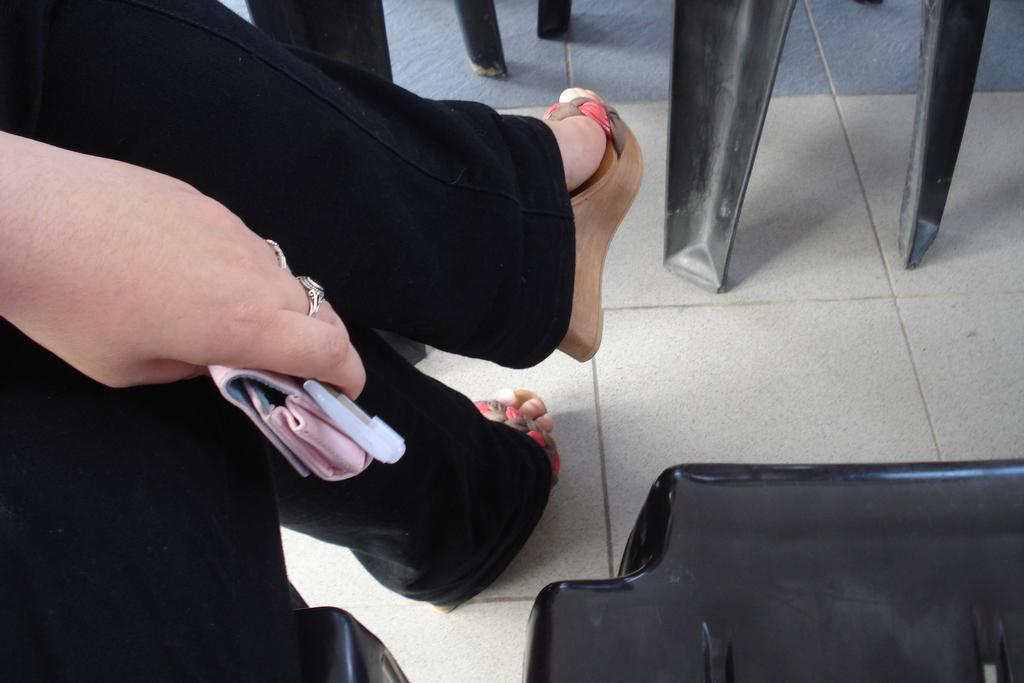What type of furniture is present in the image? There are chairs in the image. What is the person on the left side of the image doing? The person is sitting on the left side of the image. What is the person holding in their hand? The person is holding a pen and a pouch. Is the person in the image a beginner at using a pen? There is no information in the image to determine the person's level of experience with using a pen. Can you see any balls in the image? There are no balls present in the image. 